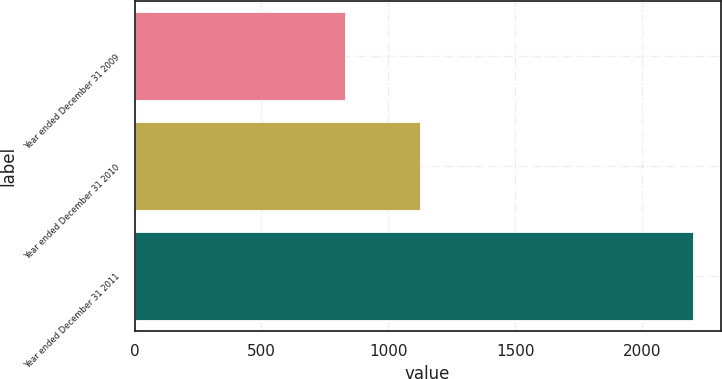Convert chart to OTSL. <chart><loc_0><loc_0><loc_500><loc_500><bar_chart><fcel>Year ended December 31 2009<fcel>Year ended December 31 2010<fcel>Year ended December 31 2011<nl><fcel>831<fcel>1125<fcel>2199<nl></chart> 